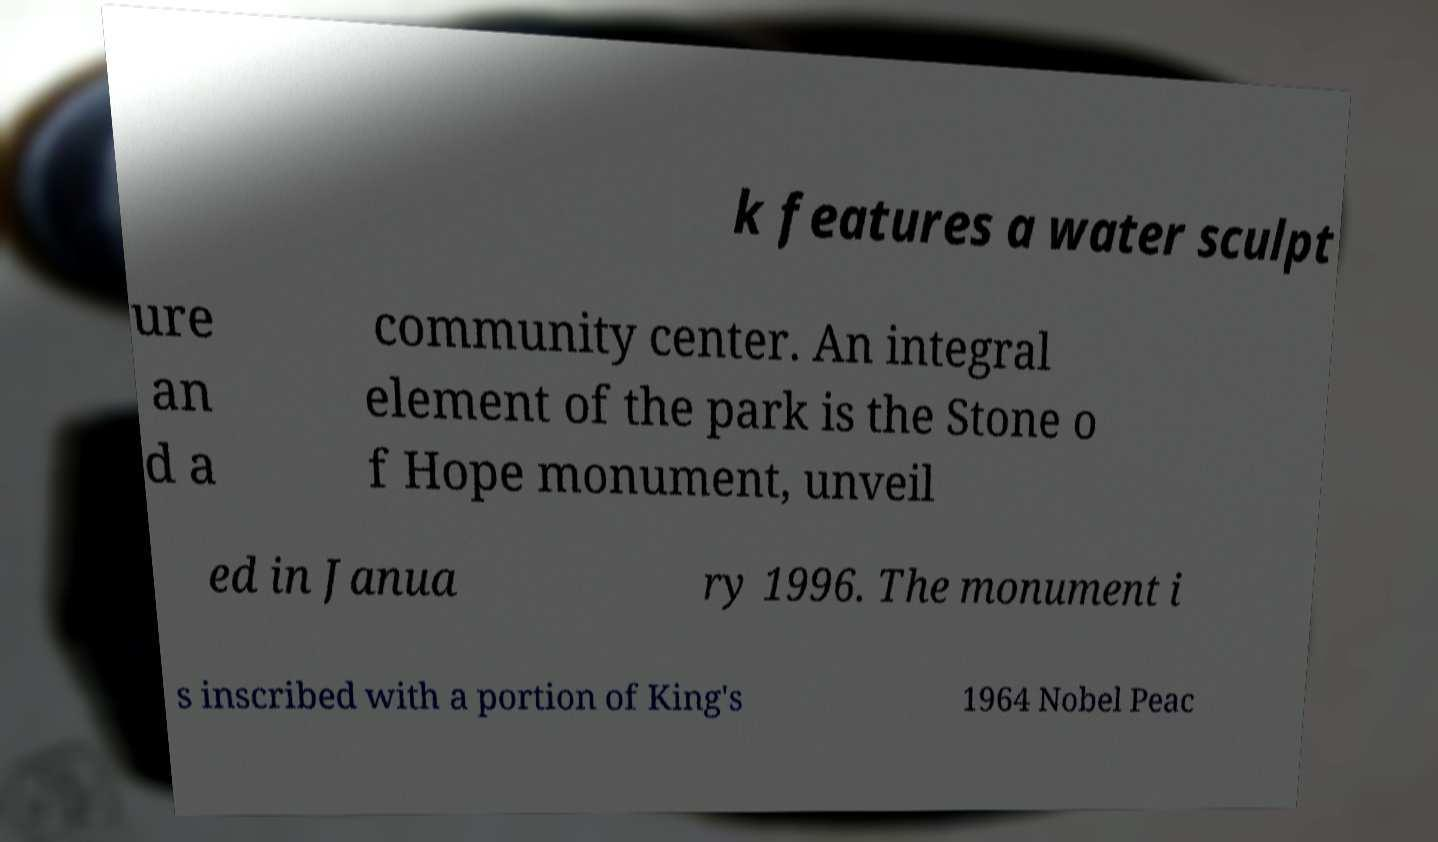Can you read and provide the text displayed in the image?This photo seems to have some interesting text. Can you extract and type it out for me? k features a water sculpt ure an d a community center. An integral element of the park is the Stone o f Hope monument, unveil ed in Janua ry 1996. The monument i s inscribed with a portion of King's 1964 Nobel Peac 